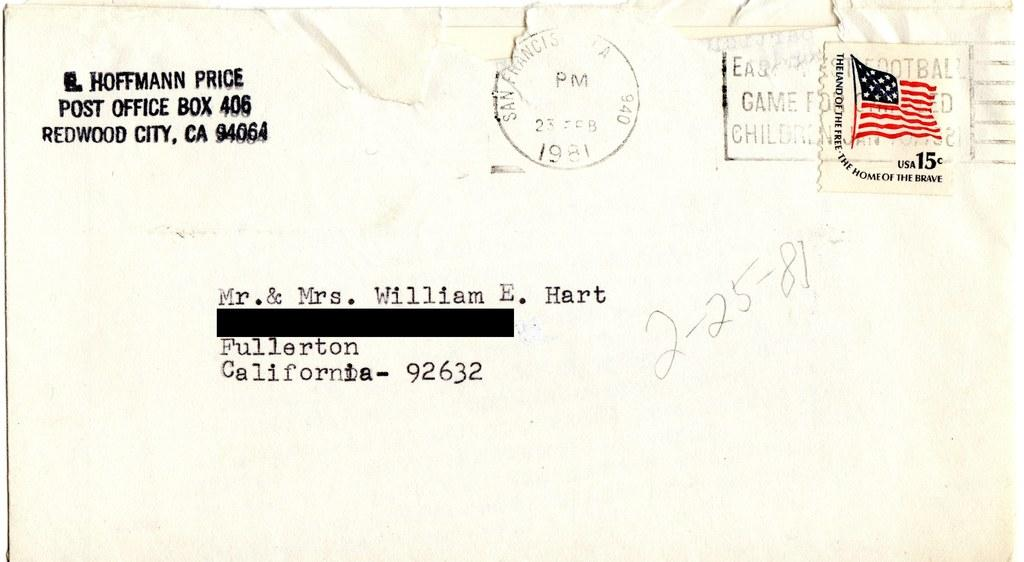<image>
Provide a brief description of the given image. A white envelope from E. Hoffmann Price addressed to Mr. & Mrs. William E. Hart 